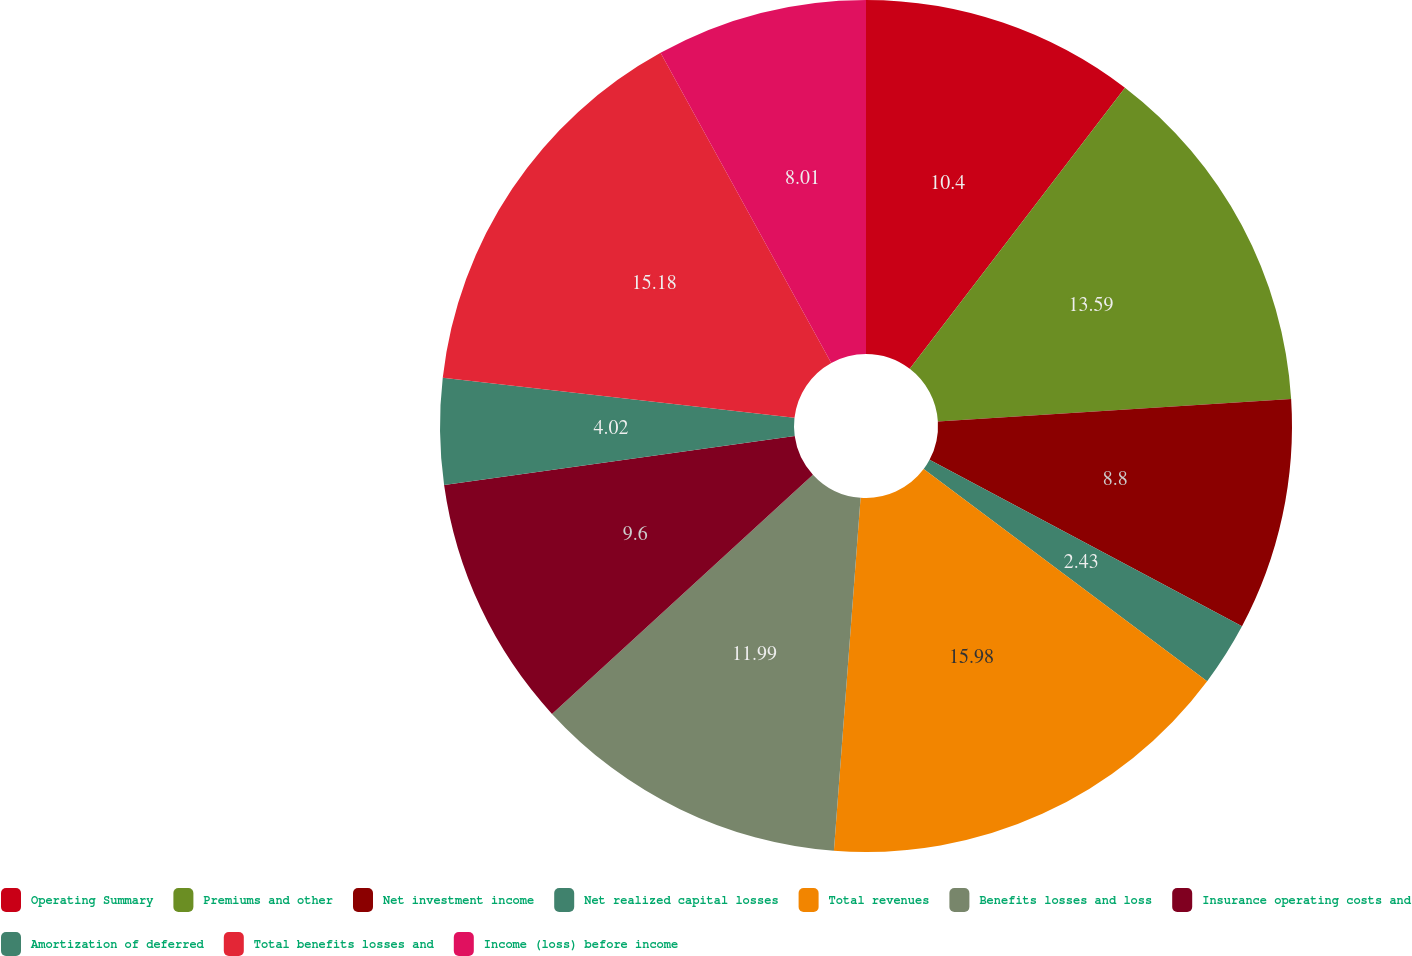Convert chart. <chart><loc_0><loc_0><loc_500><loc_500><pie_chart><fcel>Operating Summary<fcel>Premiums and other<fcel>Net investment income<fcel>Net realized capital losses<fcel>Total revenues<fcel>Benefits losses and loss<fcel>Insurance operating costs and<fcel>Amortization of deferred<fcel>Total benefits losses and<fcel>Income (loss) before income<nl><fcel>10.4%<fcel>13.59%<fcel>8.8%<fcel>2.43%<fcel>15.98%<fcel>11.99%<fcel>9.6%<fcel>4.02%<fcel>15.18%<fcel>8.01%<nl></chart> 